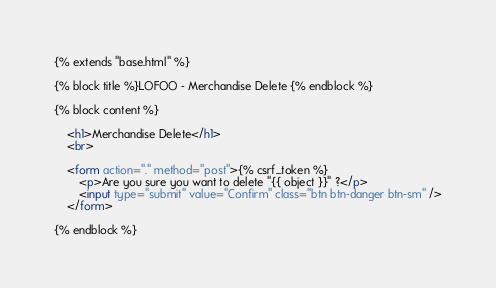<code> <loc_0><loc_0><loc_500><loc_500><_HTML_>{% extends "base.html" %}

{% block title %}LOFOO - Merchandise Delete {% endblock %}

{% block content %}

    <h1>Merchandise Delete</h1>
    <br>

    <form action="." method="post">{% csrf_token %}
        <p>Are you sure you want to delete "{{ object }}" ?</p>
        <input type="submit" value="Confirm" class="btn btn-danger btn-sm" />
    </form>

{% endblock %}

</code> 